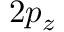<formula> <loc_0><loc_0><loc_500><loc_500>2 p _ { z }</formula> 